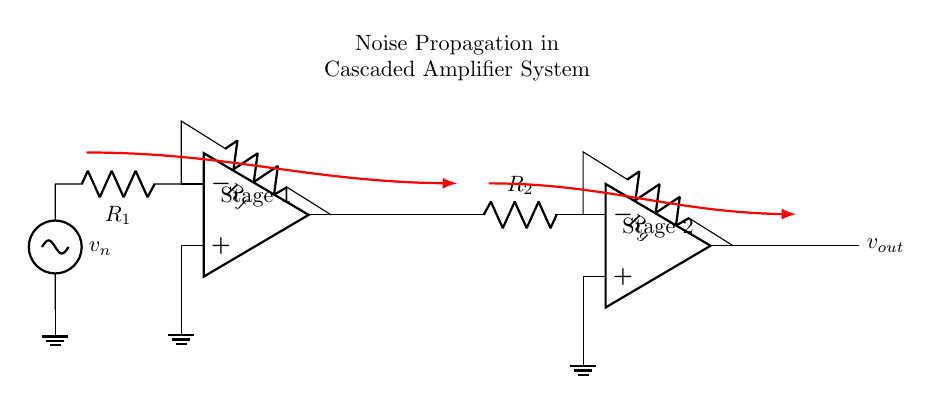What is the type of components used in this circuit? The circuit contains operational amplifiers, resistors, and a voltage source. These are identifiable by their symbols in the circuit.
Answer: operational amplifiers, resistors, voltage source How many amplifier stages are present in this circuit? There are two operational amplifiers shown in the diagram, which indicates that this circuit has two amplifier stages.
Answer: two What is the role of the resistor labeled Rf? The resistor labeled Rf is connected to the output of the first operational amplifier and feedback to the inverting input, which controls the gain of the amplifier.
Answer: gain control What is the voltage source symbolizing in the circuit? The voltage source is represented as a noise source labeled vn, indicating unwanted voltage fluctuations that can affect the signal.
Answer: noise source Which direction does the noise propagate in the circuit? The noise is shown to propagate from the input of the first amplifier stage to the output of the second amplifier stage, indicating that it affects both stages.
Answer: from input to output What is the significance of the noise propagation lines in red? The red arrows indicate the path of noise through the circuit, showing how noise from the input stage can affect the output, which is crucial for analyzing overall system performance.
Answer: path of noise What does the combination of R1 and Rf determine? The combination of R1 and Rf determines the feedback network which influences the input impedance and gain of the first amplifier stage.
Answer: input impedance and gain 